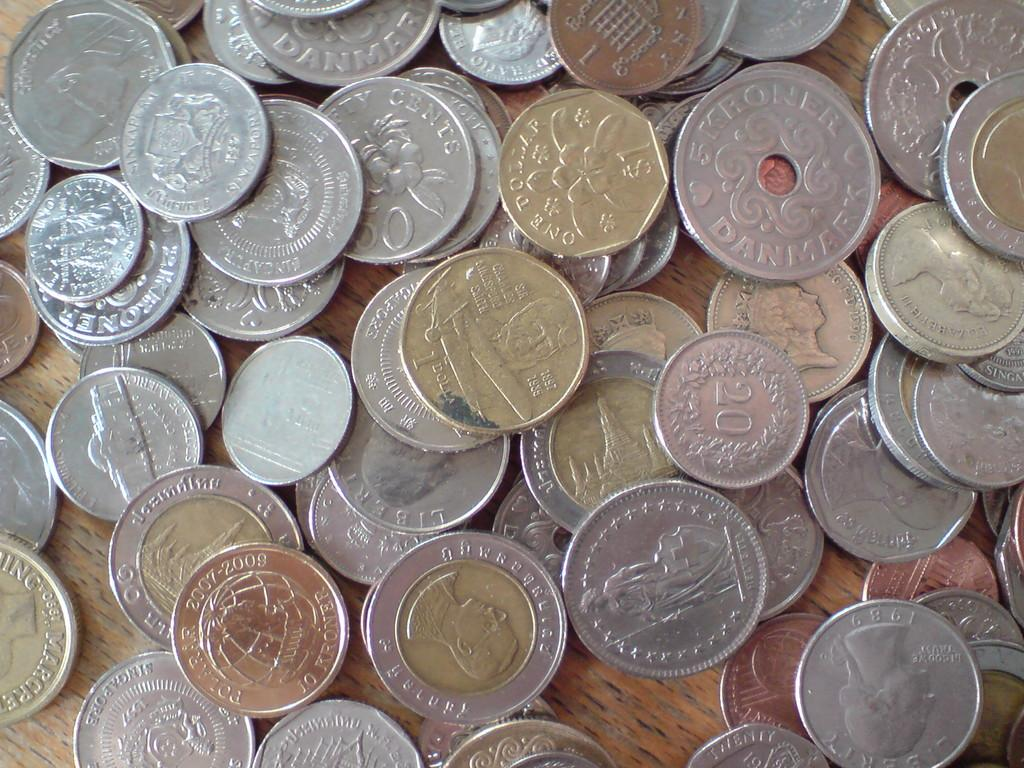<image>
Create a compact narrative representing the image presented. A collection of coins with a bronze one forward left with the dates 2007-2009 on it. 